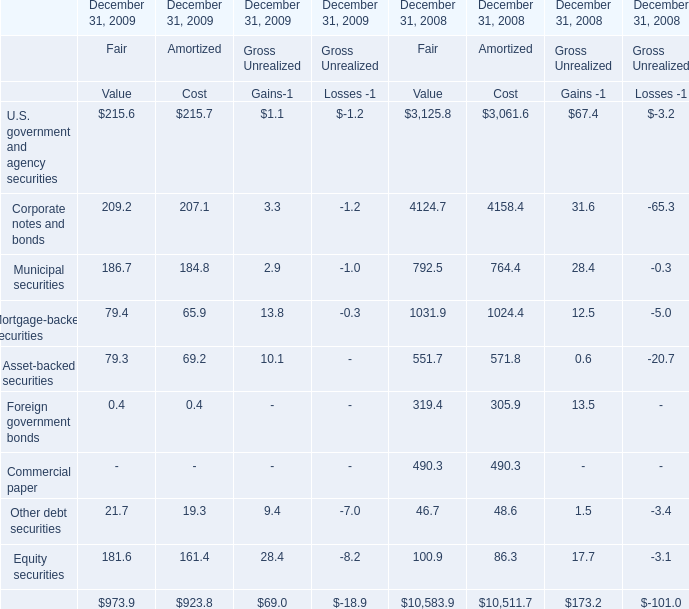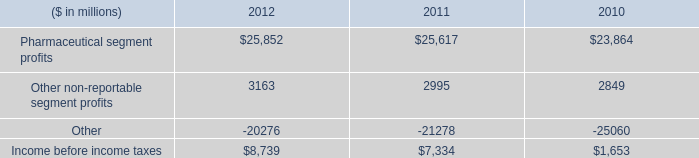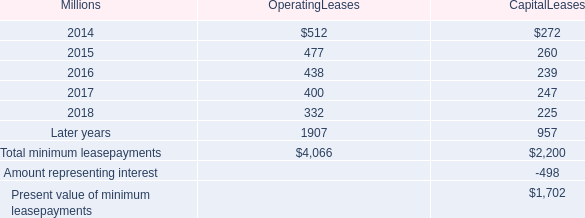In the year with largest amount of U.S. government and agency securities, what's the increasing rate of Corporate notes and bonds for Fair Value? 
Computations: ((209.2 - 4124.7) / 4124.7)
Answer: -0.94928. 